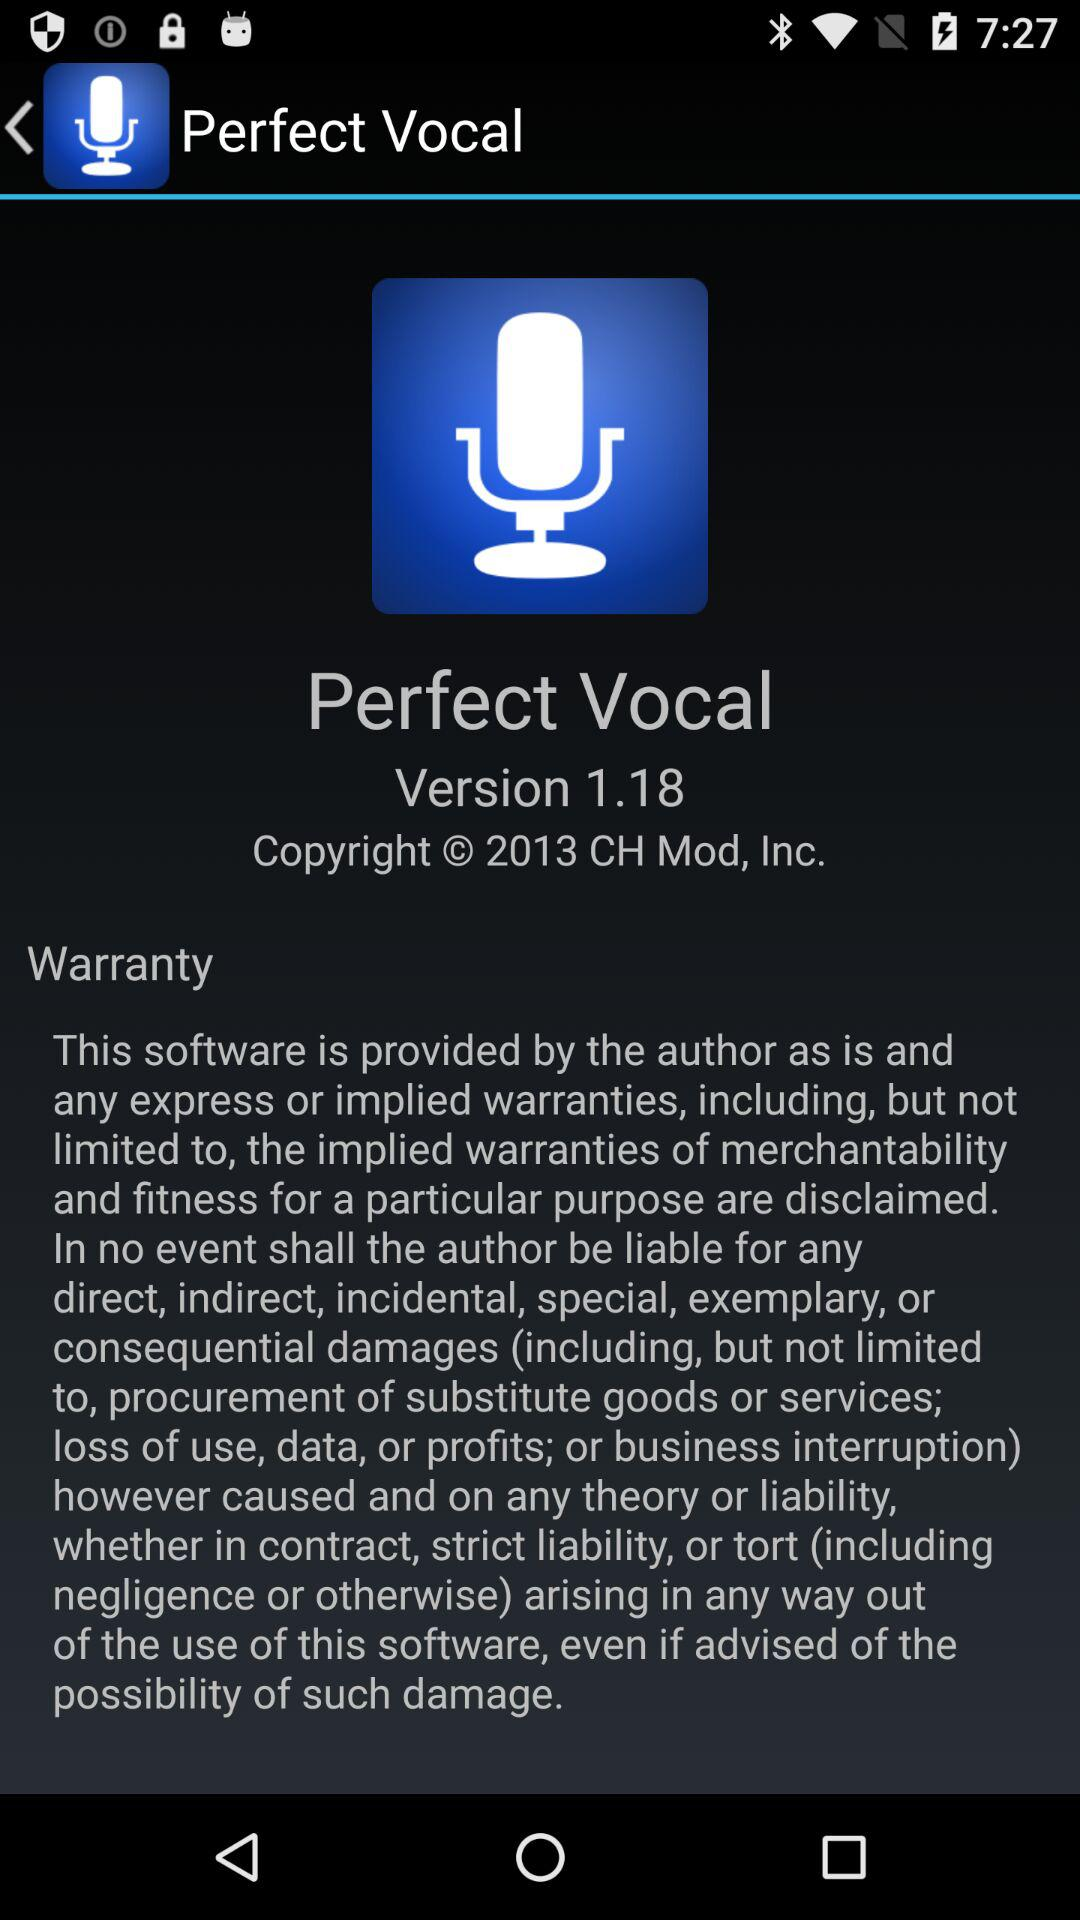What is the given version? The given version is 1.18. 